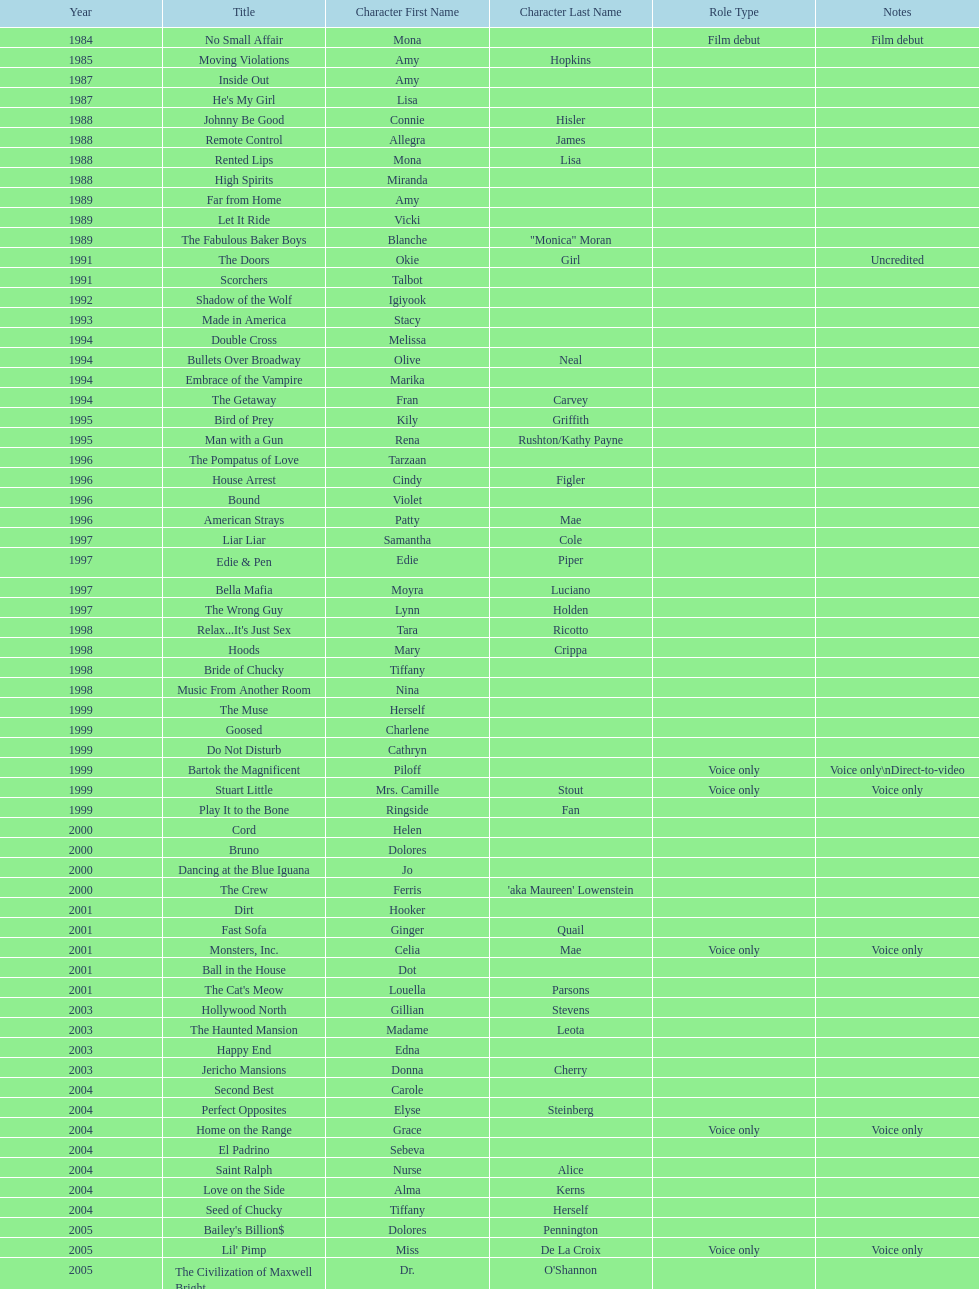I'm looking to parse the entire table for insights. Could you assist me with that? {'header': ['Year', 'Title', 'Character First Name', 'Character Last Name', 'Role Type', 'Notes'], 'rows': [['1984', 'No Small Affair', 'Mona', '', 'Film debut', 'Film debut'], ['1985', 'Moving Violations', 'Amy', 'Hopkins', '', ''], ['1987', 'Inside Out', 'Amy', '', '', ''], ['1987', "He's My Girl", 'Lisa', '', '', ''], ['1988', 'Johnny Be Good', 'Connie', 'Hisler', '', ''], ['1988', 'Remote Control', 'Allegra', 'James', '', ''], ['1988', 'Rented Lips', 'Mona', 'Lisa', '', ''], ['1988', 'High Spirits', 'Miranda', '', '', ''], ['1989', 'Far from Home', 'Amy', '', '', ''], ['1989', 'Let It Ride', 'Vicki', '', '', ''], ['1989', 'The Fabulous Baker Boys', 'Blanche', '"Monica" Moran', '', ''], ['1991', 'The Doors', 'Okie', 'Girl', '', 'Uncredited'], ['1991', 'Scorchers', 'Talbot', '', '', ''], ['1992', 'Shadow of the Wolf', 'Igiyook', '', '', ''], ['1993', 'Made in America', 'Stacy', '', '', ''], ['1994', 'Double Cross', 'Melissa', '', '', ''], ['1994', 'Bullets Over Broadway', 'Olive', 'Neal', '', ''], ['1994', 'Embrace of the Vampire', 'Marika', '', '', ''], ['1994', 'The Getaway', 'Fran', 'Carvey', '', ''], ['1995', 'Bird of Prey', 'Kily', 'Griffith', '', ''], ['1995', 'Man with a Gun', 'Rena', 'Rushton/Kathy Payne', '', ''], ['1996', 'The Pompatus of Love', 'Tarzaan', '', '', ''], ['1996', 'House Arrest', 'Cindy', 'Figler', '', ''], ['1996', 'Bound', 'Violet', '', '', ''], ['1996', 'American Strays', 'Patty', 'Mae', '', ''], ['1997', 'Liar Liar', 'Samantha', 'Cole', '', ''], ['1997', 'Edie & Pen', 'Edie', 'Piper', '', ''], ['1997', 'Bella Mafia', 'Moyra', 'Luciano', '', ''], ['1997', 'The Wrong Guy', 'Lynn', 'Holden', '', ''], ['1998', "Relax...It's Just Sex", 'Tara', 'Ricotto', '', ''], ['1998', 'Hoods', 'Mary', 'Crippa', '', ''], ['1998', 'Bride of Chucky', 'Tiffany', '', '', ''], ['1998', 'Music From Another Room', 'Nina', '', '', ''], ['1999', 'The Muse', 'Herself', '', '', ''], ['1999', 'Goosed', 'Charlene', '', '', ''], ['1999', 'Do Not Disturb', 'Cathryn', '', '', ''], ['1999', 'Bartok the Magnificent', 'Piloff', '', 'Voice only', 'Voice only\\nDirect-to-video'], ['1999', 'Stuart Little', 'Mrs. Camille', 'Stout', 'Voice only', 'Voice only'], ['1999', 'Play It to the Bone', 'Ringside', 'Fan', '', ''], ['2000', 'Cord', 'Helen', '', '', ''], ['2000', 'Bruno', 'Dolores', '', '', ''], ['2000', 'Dancing at the Blue Iguana', 'Jo', '', '', ''], ['2000', 'The Crew', 'Ferris', "'aka Maureen' Lowenstein", '', ''], ['2001', 'Dirt', 'Hooker', '', '', ''], ['2001', 'Fast Sofa', 'Ginger', 'Quail', '', ''], ['2001', 'Monsters, Inc.', 'Celia', 'Mae', 'Voice only', 'Voice only'], ['2001', 'Ball in the House', 'Dot', '', '', ''], ['2001', "The Cat's Meow", 'Louella', 'Parsons', '', ''], ['2003', 'Hollywood North', 'Gillian', 'Stevens', '', ''], ['2003', 'The Haunted Mansion', 'Madame', 'Leota', '', ''], ['2003', 'Happy End', 'Edna', '', '', ''], ['2003', 'Jericho Mansions', 'Donna', 'Cherry', '', ''], ['2004', 'Second Best', 'Carole', '', '', ''], ['2004', 'Perfect Opposites', 'Elyse', 'Steinberg', '', ''], ['2004', 'Home on the Range', 'Grace', '', 'Voice only', 'Voice only'], ['2004', 'El Padrino', 'Sebeva', '', '', ''], ['2004', 'Saint Ralph', 'Nurse', 'Alice', '', ''], ['2004', 'Love on the Side', 'Alma', 'Kerns', '', ''], ['2004', 'Seed of Chucky', 'Tiffany', 'Herself', '', ''], ['2005', "Bailey's Billion$", 'Dolores', 'Pennington', '', ''], ['2005', "Lil' Pimp", 'Miss', 'De La Croix', 'Voice only', 'Voice only'], ['2005', 'The Civilization of Maxwell Bright', 'Dr.', "O'Shannon", '', ''], ['2005', 'Tideland', 'Queen', 'Gunhilda', '', ''], ['2006', 'The Poker Movie', 'Herself', '', '', ''], ['2007', 'Intervention', '', '', '', ''], ['2008', 'Deal', 'Karen', "'Razor' Jones", '', ''], ['2008', 'The Caretaker', 'Miss', 'Perry', '', ''], ['2008', 'Bart Got a Room', 'Melinda', '', '', ''], ['2008', 'Inconceivable', 'Salome', "'Sally' Marsh", '', ''], ['2009', 'An American Girl: Chrissa Stands Strong', 'Mrs.', 'Rundell', '', ''], ['2009', 'Imps', '', '', '', ''], ['2009', 'Made in Romania', 'Herself', '', '', ''], ['2009', 'Empire of Silver', 'Mrs.', 'Landdeck', '', ''], ['2010', 'The Making of Plus One', 'Amber', '', '', ''], ['2010', 'The Secret Lives of Dorks', 'Ms.', 'Stewart', '', ''], ['2012', '30 Beats', 'Erika', '', '', ''], ['2013', 'Curse of Chucky', 'Tiffany', 'Ray', 'Cameo', 'Cameo, Direct-to-video']]} How many movies does jennifer tilly play herself? 4. 